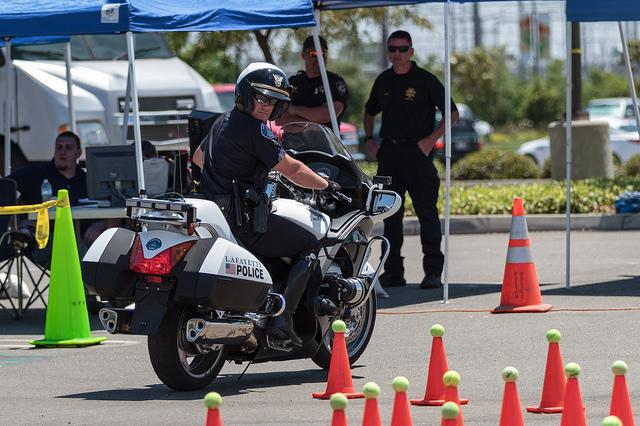Is this a casual bike rider?
Short answer required. No. What is the event?
Give a very brief answer. Fair. Is there a green cone in the picture?
Answer briefly. Yes. 